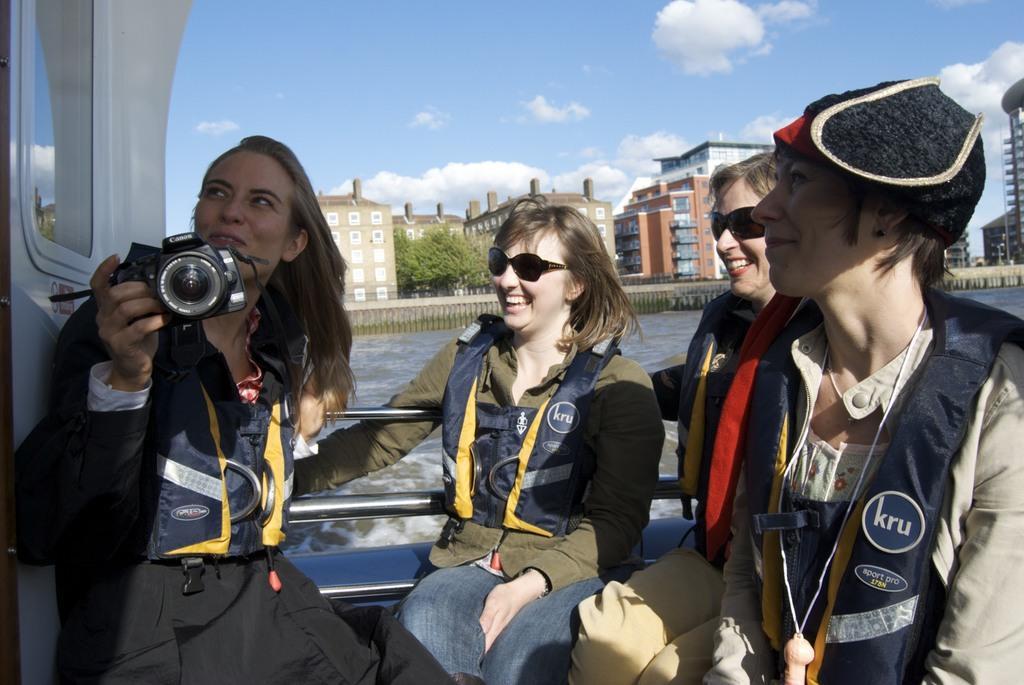In one or two sentences, can you explain what this image depicts? There are few women in the ship. On the left a woman is holding camera in her hand. In the background there are buildings,trees,water,sky and clouds. 